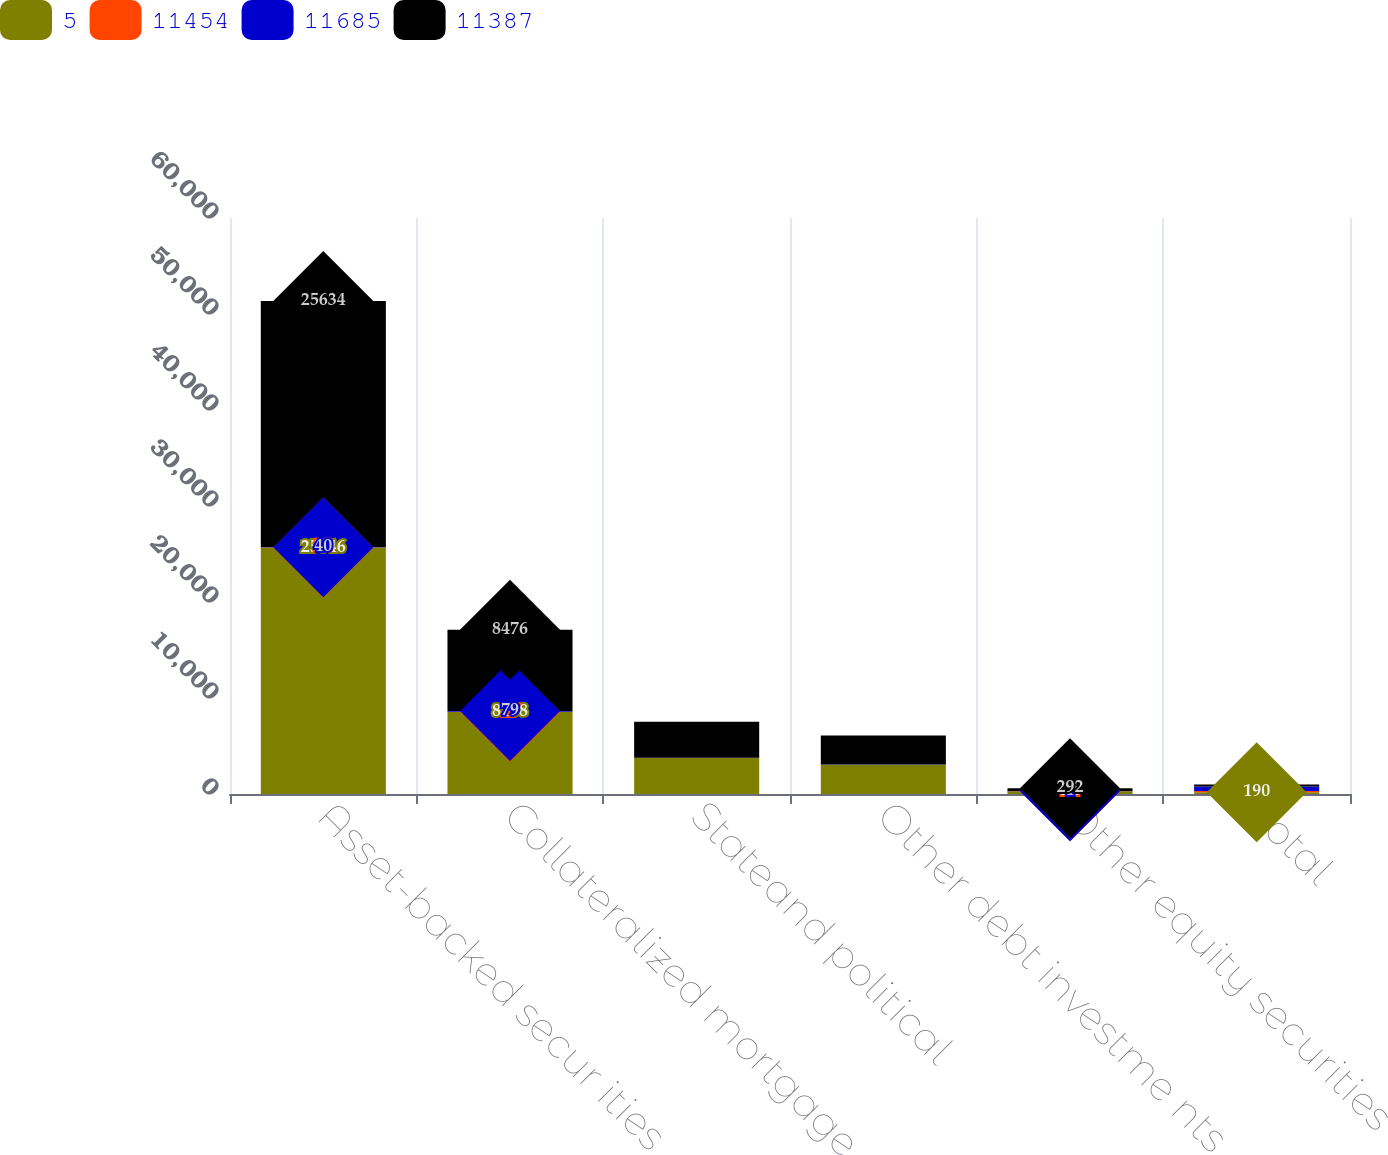Convert chart to OTSL. <chart><loc_0><loc_0><loc_500><loc_500><stacked_bar_chart><ecel><fcel>Asset-backed secur ities<fcel>Collateralized mortgage<fcel>Stateand political<fcel>Other debt investme nts<fcel>Other equity securities<fcel>Total<nl><fcel>5<fcel>25646<fcel>8538<fcel>3740<fcel>3043<fcel>269<fcel>190<nl><fcel>11454<fcel>28<fcel>17<fcel>20<fcel>7<fcel>24<fcel>111<nl><fcel>11685<fcel>40<fcel>79<fcel>11<fcel>23<fcel>1<fcel>489<nl><fcel>11387<fcel>25634<fcel>8476<fcel>3749<fcel>3027<fcel>292<fcel>190<nl></chart> 